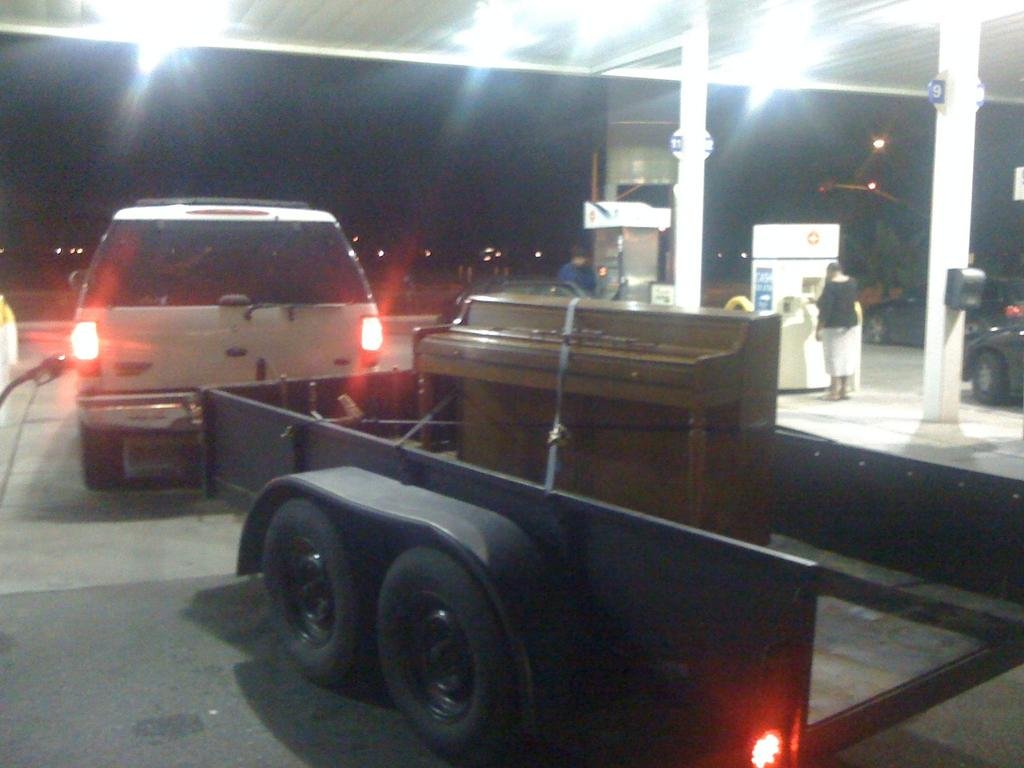What is happening in the image? There is a vehicle at a petrol pump in the image. Are there any people present in the image? Yes, there are people standing in the top right corner of the image. What can be seen in the upper part of the image? There is a roof and lights visible in the top part of the image. What is the thrill level of the vehicle in the image? The image does not provide information about the thrill level of the vehicle. --- Facts: 1. There is a person holding a book in the image. 2. The person is sitting on a chair. 3. There is a table in front of the person. 4. The book has a blue cover. 5. The chair has a cushion. Absurd Topics: ocean, dance, laughter Conversation: What is the person in the image doing? The person is holding a book in the image. What is the person sitting on? The person is sitting on a chair. What is in front of the person? There is a table in front of the person. What color is the book's cover? The book has a blue cover. What is the chair's condition? The chair has a cushion. Reasoning: Let's think step by step in order to produce the conversation. We start by identifying the main subject in the image, which is the person holding a book. Then, we expand the conversation to include other details, such as the person's sitting position, the presence of a table, the color of the book's cover, and the chair's condition. Each question is designed to elicit a specific detail about the image that is known from the provided facts. Absurd Question/Answer: Can you hear the laughter of the person reading the book in the image? The image does not provide information about the person's laughter or any sounds. 